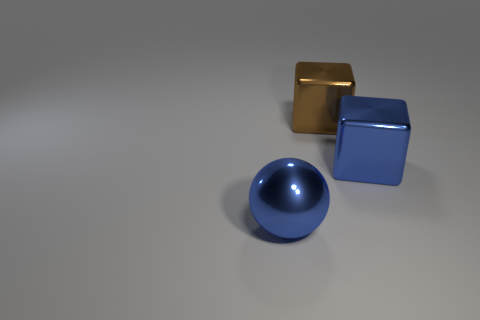Add 2 blue matte balls. How many objects exist? 5 Subtract all balls. How many objects are left? 2 Add 2 big spheres. How many big spheres are left? 3 Add 1 blue metallic blocks. How many blue metallic blocks exist? 2 Subtract 0 purple balls. How many objects are left? 3 Subtract all tiny yellow things. Subtract all large brown blocks. How many objects are left? 2 